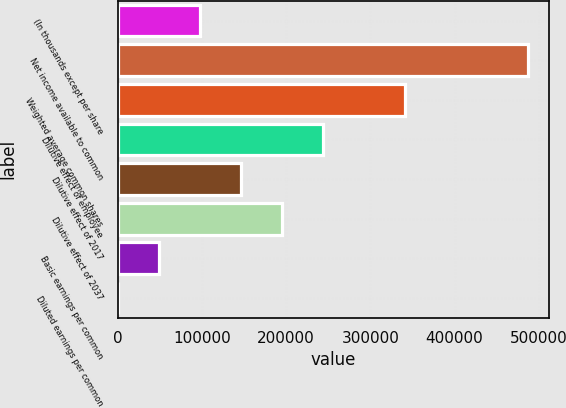Convert chart. <chart><loc_0><loc_0><loc_500><loc_500><bar_chart><fcel>(In thousands except per share<fcel>Net income available to common<fcel>Weighted average common shares<fcel>Dilutive effect of employee<fcel>Dilutive effect of 2017<fcel>Dilutive effect of 2037<fcel>Basic earnings per common<fcel>Diluted earnings per common<nl><fcel>97508.6<fcel>487536<fcel>341276<fcel>243769<fcel>146262<fcel>195015<fcel>48755.2<fcel>1.79<nl></chart> 